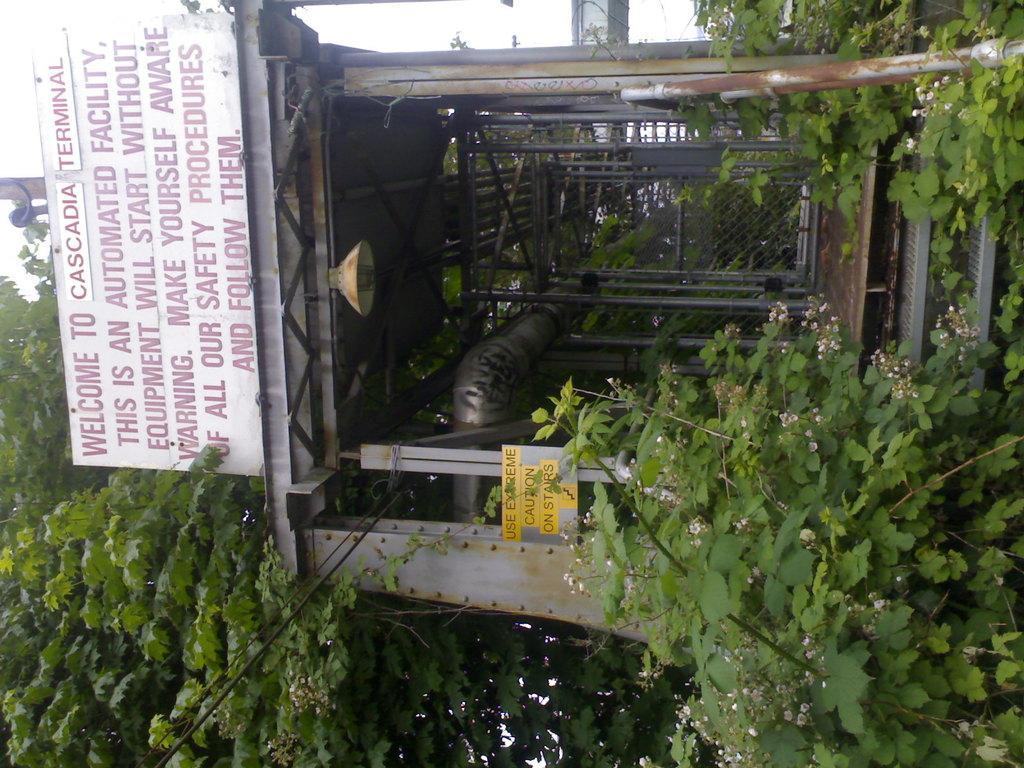Could you give a brief overview of what you see in this image? This image is taken outdoors. In this image there is a transformer and there is a board with a text on it and there are many trees and plants. 